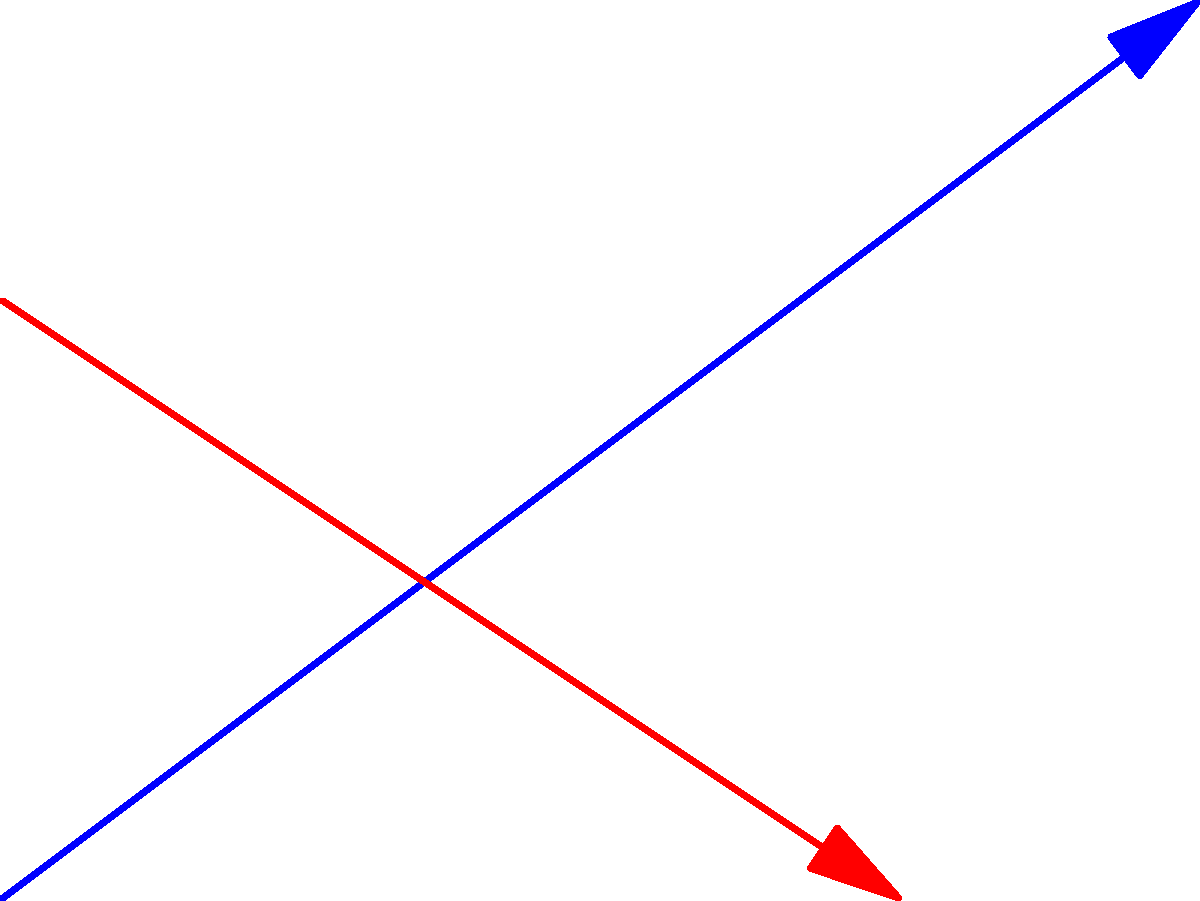In a 2D game, two characters are moving along linear paths. Character 1 moves from point A(0,0) to B(8,6), while Character 2 moves from point C(0,4) to D(6,0). Determine the coordinates of the intersection point I where these paths cross. How would you use this information for collision detection in the game? To find the intersection point of two linear paths, we can use the following steps:

1. Write equations for both lines:
   Line AB: $y = m_1x + b_1$
   Line CD: $y = m_2x + b_2$

2. Calculate the slopes:
   $m_1 = \frac{y_B - y_A}{x_B - x_A} = \frac{6 - 0}{8 - 0} = \frac{3}{4}$
   $m_2 = \frac{y_D - y_C}{x_D - x_C} = \frac{0 - 4}{6 - 0} = -\frac{2}{3}$

3. Find the y-intercepts:
   For AB: $0 = \frac{3}{4}(0) + b_1$, so $b_1 = 0$
   For CD: $4 = -\frac{2}{3}(0) + b_2$, so $b_2 = 4$

4. Equations of the lines:
   AB: $y = \frac{3}{4}x$
   CD: $y = -\frac{2}{3}x + 4$

5. Solve for the intersection point:
   $\frac{3}{4}x = -\frac{2}{3}x + 4$
   $\frac{9}{4}x = 4$
   $x = \frac{16}{9}$

   Substitute x into either equation:
   $y = \frac{3}{4}(\frac{16}{9}) = 2$

6. The intersection point I is $(\frac{16}{9}, 2)$ or approximately (1.78, 2).

For collision detection:
- Calculate the time it takes for each character to reach point I.
- If both characters reach I at the same time, a collision occurs.
- Implement a buffer zone around I to account for character sizes and game physics.
- Use this information to trigger collision events or avoidance behaviors in the game.
Answer: Intersection point I: $(\frac{16}{9}, 2)$ ≈ (1.78, 2) 